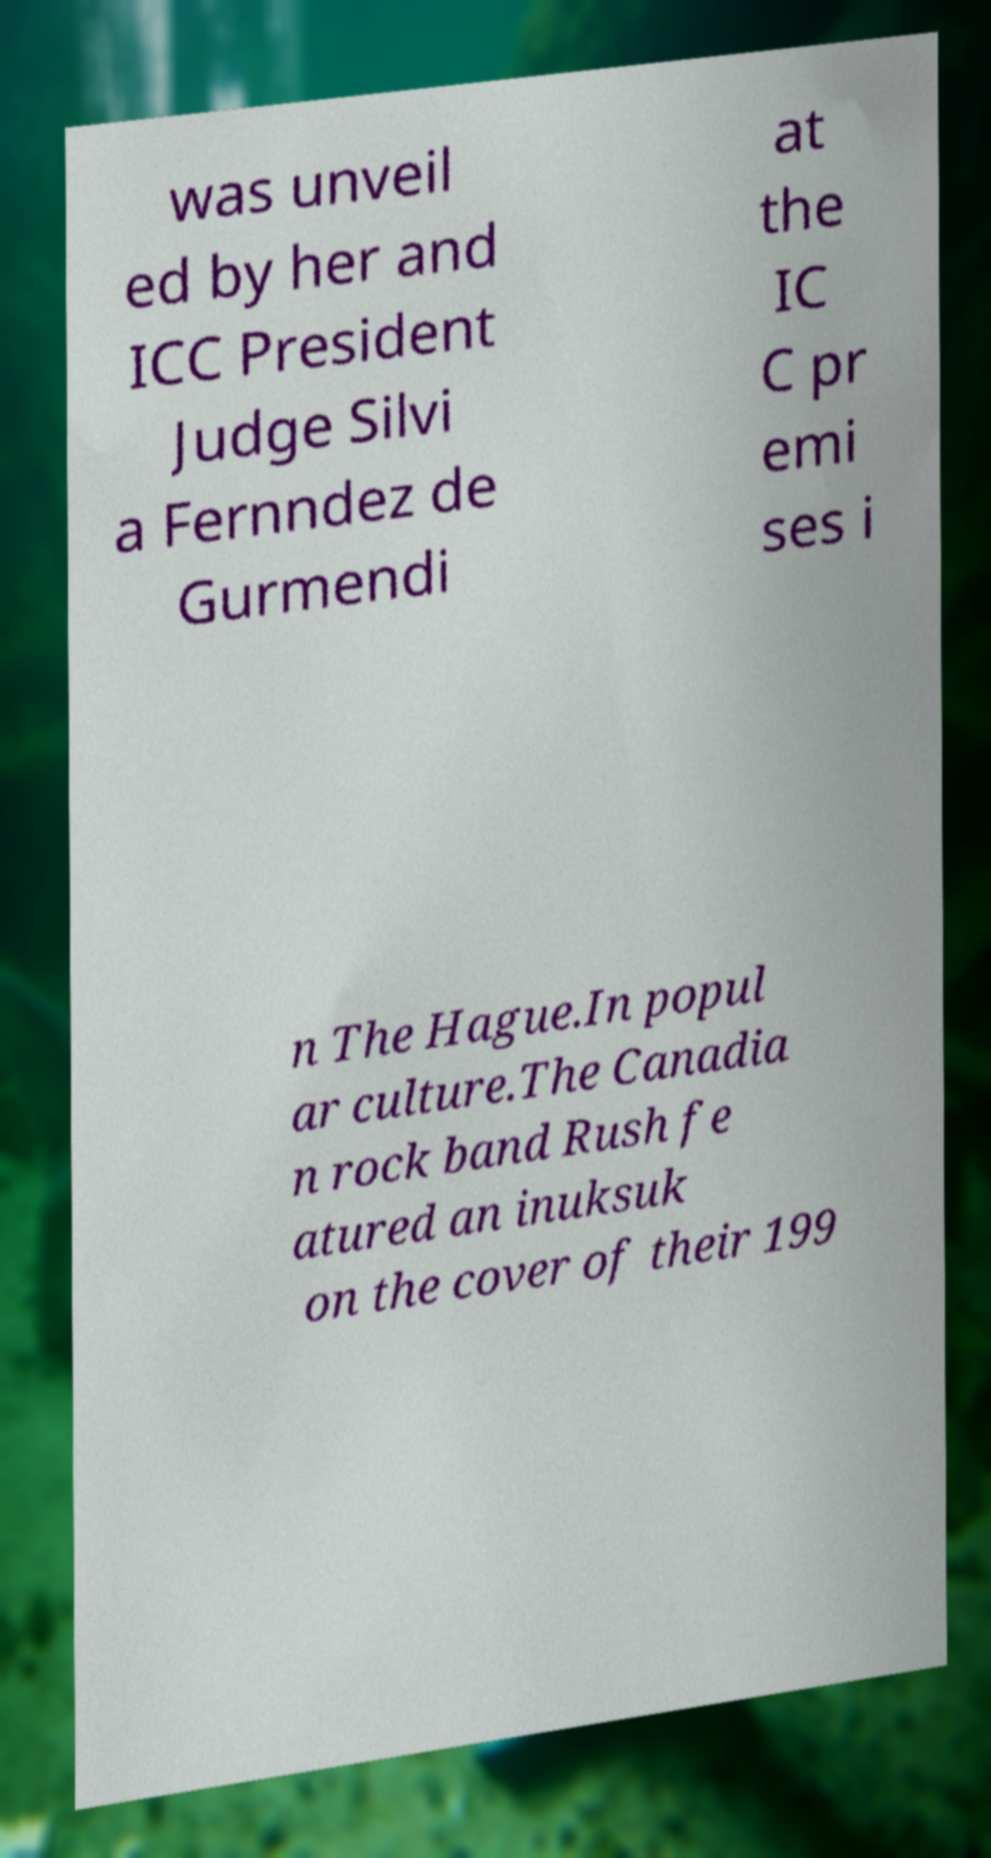What messages or text are displayed in this image? I need them in a readable, typed format. was unveil ed by her and ICC President Judge Silvi a Fernndez de Gurmendi at the IC C pr emi ses i n The Hague.In popul ar culture.The Canadia n rock band Rush fe atured an inuksuk on the cover of their 199 